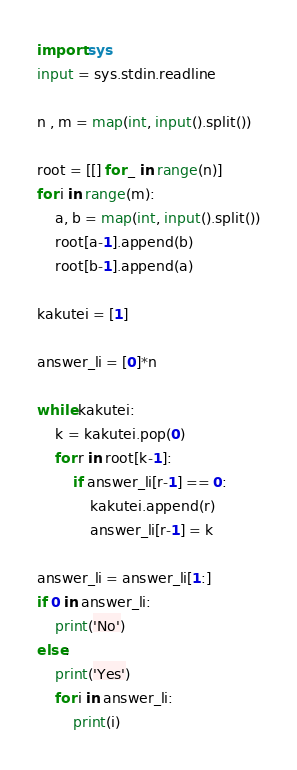<code> <loc_0><loc_0><loc_500><loc_500><_Python_>import sys
input = sys.stdin.readline

n , m = map(int, input().split())

root = [[] for _ in range(n)]
for i in range(m):
    a, b = map(int, input().split())
    root[a-1].append(b)
    root[b-1].append(a)

kakutei = [1]

answer_li = [0]*n

while kakutei:
    k = kakutei.pop(0)
    for r in root[k-1]:
        if answer_li[r-1] == 0:
            kakutei.append(r)
            answer_li[r-1] = k

answer_li = answer_li[1:]
if 0 in answer_li:
    print('No')
else:
    print('Yes')
    for i in answer_li:
        print(i)
</code> 